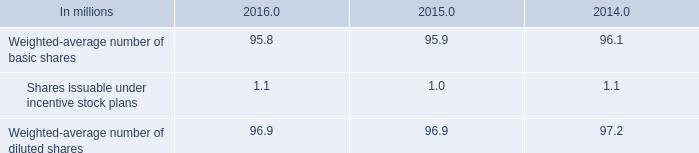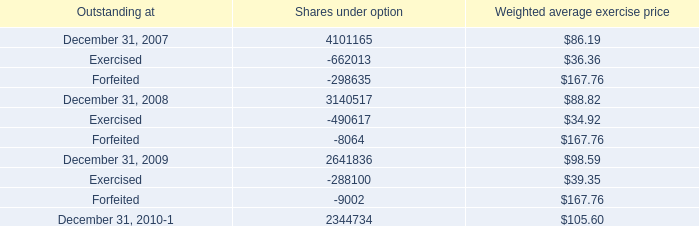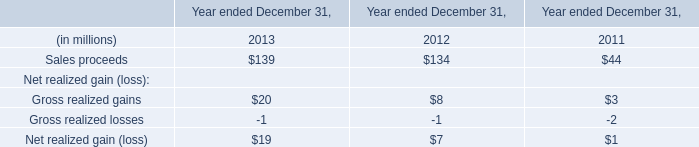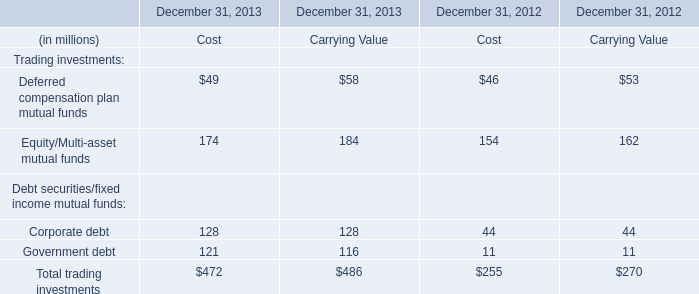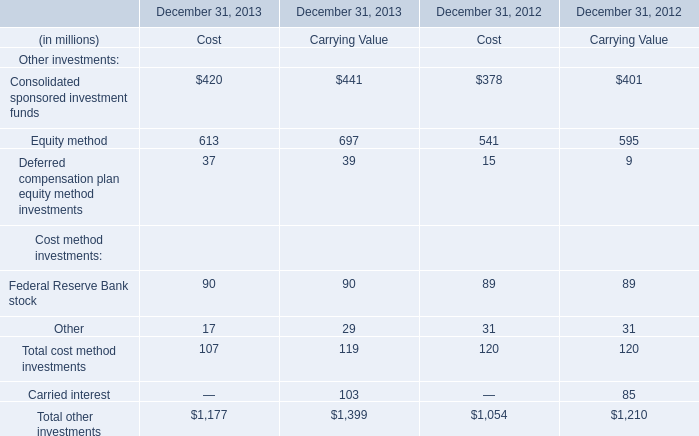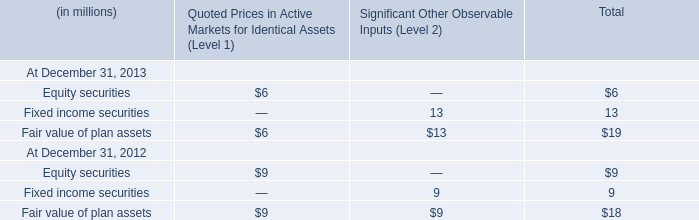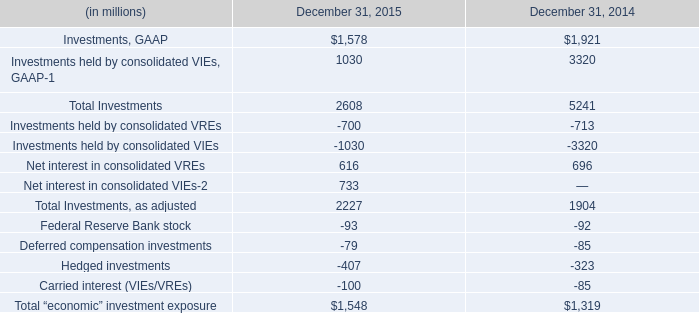What's the average of Consolidated sponsored investment funds and Equity method and Deferred compensation plan equity method investments in 2013? (in million) 
Computations: (((420 + 613) + 37) / 3)
Answer: 356.66667. 